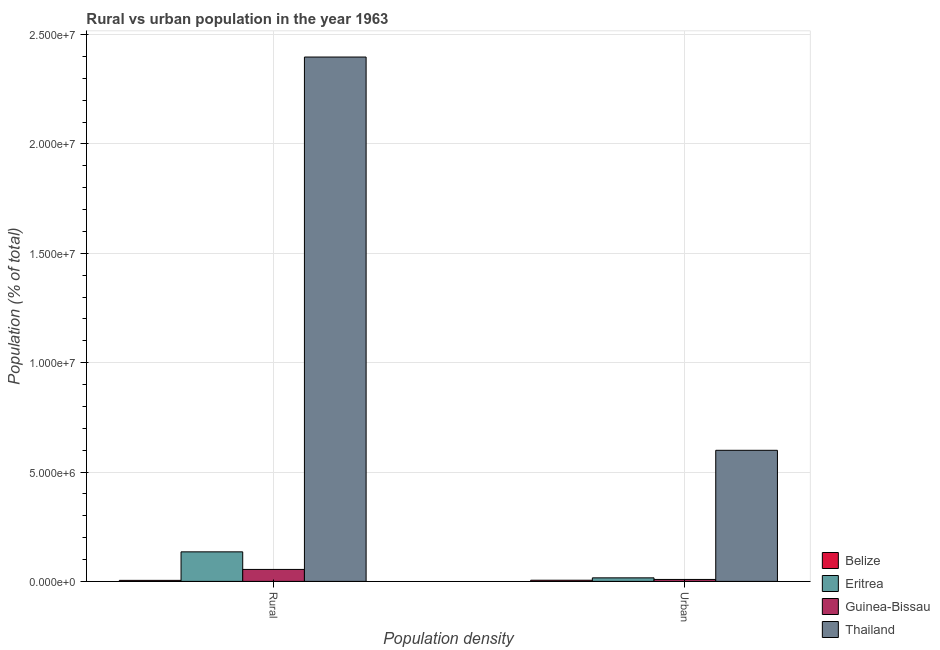How many different coloured bars are there?
Make the answer very short. 4. How many groups of bars are there?
Make the answer very short. 2. Are the number of bars per tick equal to the number of legend labels?
Keep it short and to the point. Yes. Are the number of bars on each tick of the X-axis equal?
Your answer should be compact. Yes. How many bars are there on the 1st tick from the left?
Provide a short and direct response. 4. How many bars are there on the 1st tick from the right?
Make the answer very short. 4. What is the label of the 1st group of bars from the left?
Keep it short and to the point. Rural. What is the rural population density in Thailand?
Provide a short and direct response. 2.40e+07. Across all countries, what is the maximum rural population density?
Provide a short and direct response. 2.40e+07. Across all countries, what is the minimum urban population density?
Keep it short and to the point. 5.32e+04. In which country was the rural population density maximum?
Provide a succinct answer. Thailand. In which country was the urban population density minimum?
Ensure brevity in your answer.  Belize. What is the total urban population density in the graph?
Your answer should be compact. 6.30e+06. What is the difference between the rural population density in Guinea-Bissau and that in Thailand?
Your answer should be compact. -2.34e+07. What is the difference between the urban population density in Thailand and the rural population density in Guinea-Bissau?
Offer a very short reply. 5.45e+06. What is the average urban population density per country?
Offer a very short reply. 1.57e+06. What is the difference between the urban population density and rural population density in Eritrea?
Make the answer very short. -1.19e+06. In how many countries, is the rural population density greater than 23000000 %?
Keep it short and to the point. 1. What is the ratio of the urban population density in Belize to that in Guinea-Bissau?
Offer a very short reply. 0.59. What does the 4th bar from the left in Rural represents?
Keep it short and to the point. Thailand. What does the 2nd bar from the right in Rural represents?
Your response must be concise. Guinea-Bissau. How many bars are there?
Provide a succinct answer. 8. How many countries are there in the graph?
Provide a short and direct response. 4. Does the graph contain any zero values?
Give a very brief answer. No. Does the graph contain grids?
Ensure brevity in your answer.  Yes. Where does the legend appear in the graph?
Offer a very short reply. Bottom right. How many legend labels are there?
Your answer should be very brief. 4. How are the legend labels stacked?
Offer a terse response. Vertical. What is the title of the graph?
Give a very brief answer. Rural vs urban population in the year 1963. What is the label or title of the X-axis?
Offer a very short reply. Population density. What is the label or title of the Y-axis?
Provide a short and direct response. Population (% of total). What is the Population (% of total) of Belize in Rural?
Provide a succinct answer. 4.70e+04. What is the Population (% of total) in Eritrea in Rural?
Keep it short and to the point. 1.35e+06. What is the Population (% of total) of Guinea-Bissau in Rural?
Your answer should be very brief. 5.47e+05. What is the Population (% of total) in Thailand in Rural?
Give a very brief answer. 2.40e+07. What is the Population (% of total) of Belize in Urban?
Offer a very short reply. 5.32e+04. What is the Population (% of total) of Eritrea in Urban?
Provide a succinct answer. 1.62e+05. What is the Population (% of total) of Guinea-Bissau in Urban?
Offer a very short reply. 8.94e+04. What is the Population (% of total) of Thailand in Urban?
Your answer should be very brief. 5.99e+06. Across all Population density, what is the maximum Population (% of total) of Belize?
Give a very brief answer. 5.32e+04. Across all Population density, what is the maximum Population (% of total) of Eritrea?
Provide a succinct answer. 1.35e+06. Across all Population density, what is the maximum Population (% of total) in Guinea-Bissau?
Give a very brief answer. 5.47e+05. Across all Population density, what is the maximum Population (% of total) in Thailand?
Offer a very short reply. 2.40e+07. Across all Population density, what is the minimum Population (% of total) in Belize?
Your answer should be very brief. 4.70e+04. Across all Population density, what is the minimum Population (% of total) of Eritrea?
Offer a terse response. 1.62e+05. Across all Population density, what is the minimum Population (% of total) of Guinea-Bissau?
Give a very brief answer. 8.94e+04. Across all Population density, what is the minimum Population (% of total) in Thailand?
Offer a very short reply. 5.99e+06. What is the total Population (% of total) of Belize in the graph?
Your answer should be compact. 1.00e+05. What is the total Population (% of total) of Eritrea in the graph?
Offer a terse response. 1.51e+06. What is the total Population (% of total) of Guinea-Bissau in the graph?
Offer a very short reply. 6.37e+05. What is the total Population (% of total) of Thailand in the graph?
Your answer should be compact. 3.00e+07. What is the difference between the Population (% of total) of Belize in Rural and that in Urban?
Offer a very short reply. -6212. What is the difference between the Population (% of total) in Eritrea in Rural and that in Urban?
Offer a very short reply. 1.19e+06. What is the difference between the Population (% of total) in Guinea-Bissau in Rural and that in Urban?
Provide a short and direct response. 4.58e+05. What is the difference between the Population (% of total) in Thailand in Rural and that in Urban?
Your answer should be compact. 1.80e+07. What is the difference between the Population (% of total) of Belize in Rural and the Population (% of total) of Eritrea in Urban?
Offer a very short reply. -1.15e+05. What is the difference between the Population (% of total) of Belize in Rural and the Population (% of total) of Guinea-Bissau in Urban?
Keep it short and to the point. -4.24e+04. What is the difference between the Population (% of total) of Belize in Rural and the Population (% of total) of Thailand in Urban?
Give a very brief answer. -5.95e+06. What is the difference between the Population (% of total) of Eritrea in Rural and the Population (% of total) of Guinea-Bissau in Urban?
Your response must be concise. 1.26e+06. What is the difference between the Population (% of total) of Eritrea in Rural and the Population (% of total) of Thailand in Urban?
Ensure brevity in your answer.  -4.64e+06. What is the difference between the Population (% of total) in Guinea-Bissau in Rural and the Population (% of total) in Thailand in Urban?
Provide a short and direct response. -5.45e+06. What is the average Population (% of total) in Belize per Population density?
Provide a short and direct response. 5.01e+04. What is the average Population (% of total) of Eritrea per Population density?
Make the answer very short. 7.56e+05. What is the average Population (% of total) of Guinea-Bissau per Population density?
Make the answer very short. 3.18e+05. What is the average Population (% of total) of Thailand per Population density?
Provide a short and direct response. 1.50e+07. What is the difference between the Population (% of total) in Belize and Population (% of total) in Eritrea in Rural?
Your answer should be very brief. -1.30e+06. What is the difference between the Population (% of total) in Belize and Population (% of total) in Guinea-Bissau in Rural?
Give a very brief answer. -5.00e+05. What is the difference between the Population (% of total) in Belize and Population (% of total) in Thailand in Rural?
Your answer should be compact. -2.39e+07. What is the difference between the Population (% of total) of Eritrea and Population (% of total) of Guinea-Bissau in Rural?
Ensure brevity in your answer.  8.04e+05. What is the difference between the Population (% of total) in Eritrea and Population (% of total) in Thailand in Rural?
Offer a terse response. -2.26e+07. What is the difference between the Population (% of total) of Guinea-Bissau and Population (% of total) of Thailand in Rural?
Make the answer very short. -2.34e+07. What is the difference between the Population (% of total) in Belize and Population (% of total) in Eritrea in Urban?
Provide a short and direct response. -1.09e+05. What is the difference between the Population (% of total) of Belize and Population (% of total) of Guinea-Bissau in Urban?
Your response must be concise. -3.62e+04. What is the difference between the Population (% of total) of Belize and Population (% of total) of Thailand in Urban?
Keep it short and to the point. -5.94e+06. What is the difference between the Population (% of total) of Eritrea and Population (% of total) of Guinea-Bissau in Urban?
Your response must be concise. 7.25e+04. What is the difference between the Population (% of total) of Eritrea and Population (% of total) of Thailand in Urban?
Your answer should be compact. -5.83e+06. What is the difference between the Population (% of total) in Guinea-Bissau and Population (% of total) in Thailand in Urban?
Offer a terse response. -5.90e+06. What is the ratio of the Population (% of total) in Belize in Rural to that in Urban?
Provide a short and direct response. 0.88. What is the ratio of the Population (% of total) in Eritrea in Rural to that in Urban?
Give a very brief answer. 8.34. What is the ratio of the Population (% of total) of Guinea-Bissau in Rural to that in Urban?
Offer a terse response. 6.12. What is the ratio of the Population (% of total) of Thailand in Rural to that in Urban?
Your answer should be very brief. 4. What is the difference between the highest and the second highest Population (% of total) in Belize?
Make the answer very short. 6212. What is the difference between the highest and the second highest Population (% of total) of Eritrea?
Keep it short and to the point. 1.19e+06. What is the difference between the highest and the second highest Population (% of total) of Guinea-Bissau?
Make the answer very short. 4.58e+05. What is the difference between the highest and the second highest Population (% of total) in Thailand?
Give a very brief answer. 1.80e+07. What is the difference between the highest and the lowest Population (% of total) in Belize?
Provide a succinct answer. 6212. What is the difference between the highest and the lowest Population (% of total) of Eritrea?
Make the answer very short. 1.19e+06. What is the difference between the highest and the lowest Population (% of total) in Guinea-Bissau?
Give a very brief answer. 4.58e+05. What is the difference between the highest and the lowest Population (% of total) in Thailand?
Your answer should be compact. 1.80e+07. 